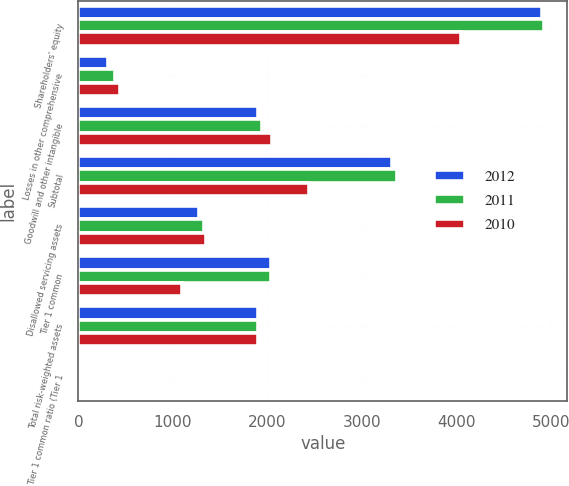<chart> <loc_0><loc_0><loc_500><loc_500><stacked_bar_chart><ecel><fcel>Shareholders' equity<fcel>Losses in other comprehensive<fcel>Goodwill and other intangible<fcel>Subtotal<fcel>Disallowed servicing assets<fcel>Tier 1 common<fcel>Total risk-weighted assets<fcel>Tier 1 common ratio (Tier 1<nl><fcel>2012<fcel>4904.5<fcel>315.4<fcel>1899.4<fcel>3320.5<fcel>1278.9<fcel>2041.6<fcel>1899.4<fcel>10.3<nl><fcel>2011<fcel>4928<fcel>389.6<fcel>1947.5<fcel>3370.1<fcel>1331<fcel>2039.1<fcel>1899.4<fcel>9.4<nl><fcel>2010<fcel>4052.4<fcel>439.9<fcel>2046.4<fcel>2445.9<fcel>1351.3<fcel>1094.6<fcel>1899.4<fcel>4.8<nl></chart> 